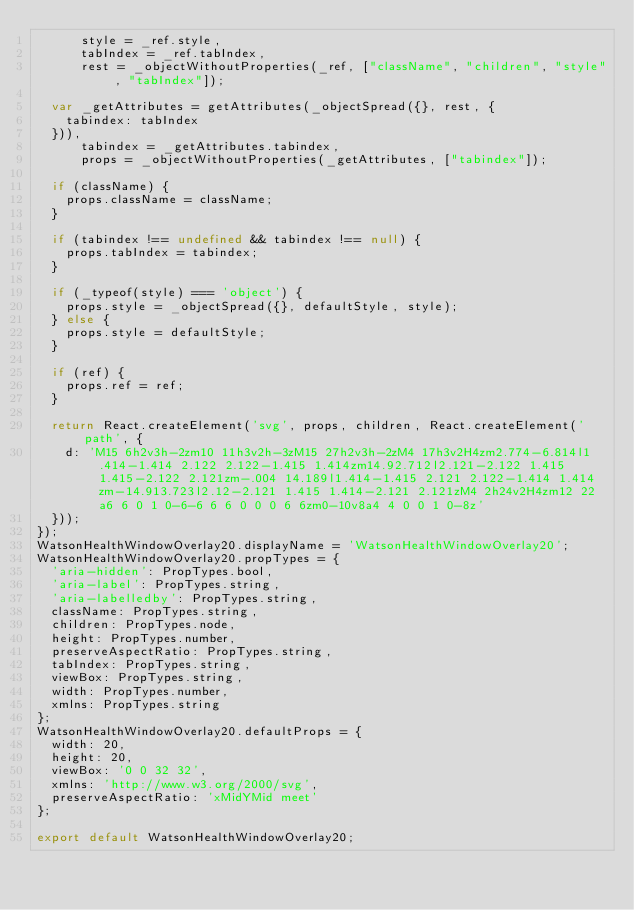<code> <loc_0><loc_0><loc_500><loc_500><_JavaScript_>      style = _ref.style,
      tabIndex = _ref.tabIndex,
      rest = _objectWithoutProperties(_ref, ["className", "children", "style", "tabIndex"]);

  var _getAttributes = getAttributes(_objectSpread({}, rest, {
    tabindex: tabIndex
  })),
      tabindex = _getAttributes.tabindex,
      props = _objectWithoutProperties(_getAttributes, ["tabindex"]);

  if (className) {
    props.className = className;
  }

  if (tabindex !== undefined && tabindex !== null) {
    props.tabIndex = tabindex;
  }

  if (_typeof(style) === 'object') {
    props.style = _objectSpread({}, defaultStyle, style);
  } else {
    props.style = defaultStyle;
  }

  if (ref) {
    props.ref = ref;
  }

  return React.createElement('svg', props, children, React.createElement('path', {
    d: 'M15 6h2v3h-2zm10 11h3v2h-3zM15 27h2v3h-2zM4 17h3v2H4zm2.774-6.814l1.414-1.414 2.122 2.122-1.415 1.414zm14.92.712l2.121-2.122 1.415 1.415-2.122 2.121zm-.004 14.189l1.414-1.415 2.121 2.122-1.414 1.414zm-14.913.723l2.12-2.121 1.415 1.414-2.121 2.121zM4 2h24v2H4zm12 22a6 6 0 1 0-6-6 6 6 0 0 0 6 6zm0-10v8a4 4 0 0 1 0-8z'
  }));
});
WatsonHealthWindowOverlay20.displayName = 'WatsonHealthWindowOverlay20';
WatsonHealthWindowOverlay20.propTypes = {
  'aria-hidden': PropTypes.bool,
  'aria-label': PropTypes.string,
  'aria-labelledby': PropTypes.string,
  className: PropTypes.string,
  children: PropTypes.node,
  height: PropTypes.number,
  preserveAspectRatio: PropTypes.string,
  tabIndex: PropTypes.string,
  viewBox: PropTypes.string,
  width: PropTypes.number,
  xmlns: PropTypes.string
};
WatsonHealthWindowOverlay20.defaultProps = {
  width: 20,
  height: 20,
  viewBox: '0 0 32 32',
  xmlns: 'http://www.w3.org/2000/svg',
  preserveAspectRatio: 'xMidYMid meet'
};

export default WatsonHealthWindowOverlay20;
</code> 